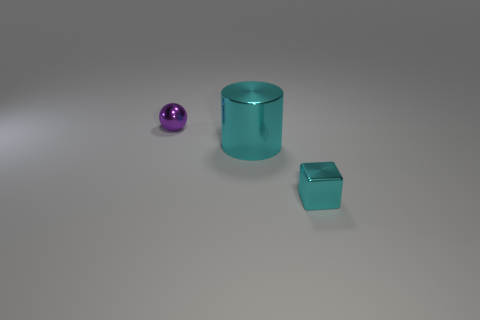How many metal objects are both behind the tiny cyan cube and right of the purple object?
Provide a short and direct response. 1. What number of blue things are tiny metallic things or shiny cubes?
Provide a short and direct response. 0. There is a tiny metallic thing in front of the big cyan shiny cylinder; is its color the same as the small shiny thing behind the cyan cylinder?
Your response must be concise. No. There is a small thing that is behind the small thing to the right of the small shiny object behind the small cube; what color is it?
Give a very brief answer. Purple. Is there a cyan block in front of the tiny thing that is behind the cylinder?
Provide a short and direct response. Yes. Are there any other things that are the same shape as the small cyan metallic thing?
Your response must be concise. No. What number of cubes are cyan metal things or red things?
Ensure brevity in your answer.  1. What number of purple metallic objects are there?
Provide a succinct answer. 1. There is a metal sphere left of the tiny metallic thing on the right side of the purple shiny sphere; what is its size?
Make the answer very short. Small. What number of other things are there of the same size as the shiny cylinder?
Ensure brevity in your answer.  0. 